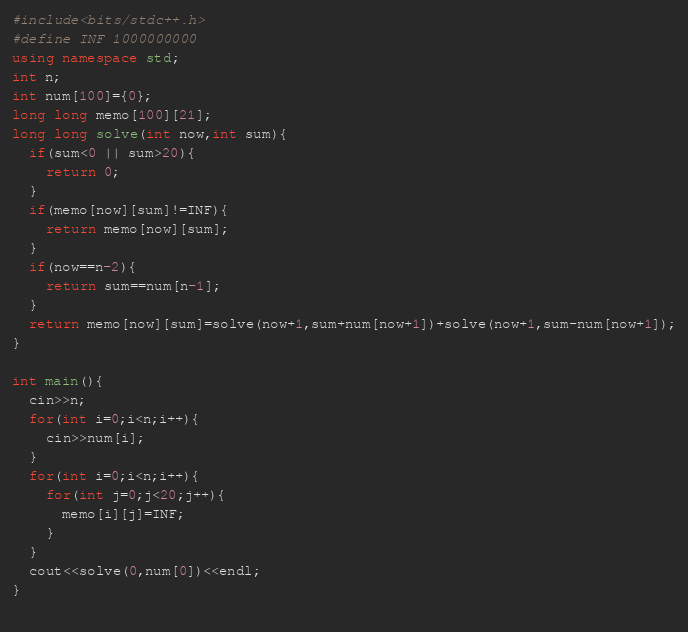Convert code to text. <code><loc_0><loc_0><loc_500><loc_500><_C++_>#include<bits/stdc++.h>
#define INF 1000000000
using namespace std;
int n;
int num[100]={0};
long long memo[100][21];
long long solve(int now,int sum){
  if(sum<0 || sum>20){
    return 0;
  }
  if(memo[now][sum]!=INF){
    return memo[now][sum];
  }
  if(now==n-2){
    return sum==num[n-1];
  }
  return memo[now][sum]=solve(now+1,sum+num[now+1])+solve(now+1,sum-num[now+1]);
}

int main(){
  cin>>n;
  for(int i=0;i<n;i++){
    cin>>num[i];
  }
  for(int i=0;i<n;i++){
    for(int j=0;j<20;j++){
      memo[i][j]=INF;
    }
  }
  cout<<solve(0,num[0])<<endl;
}
  </code> 